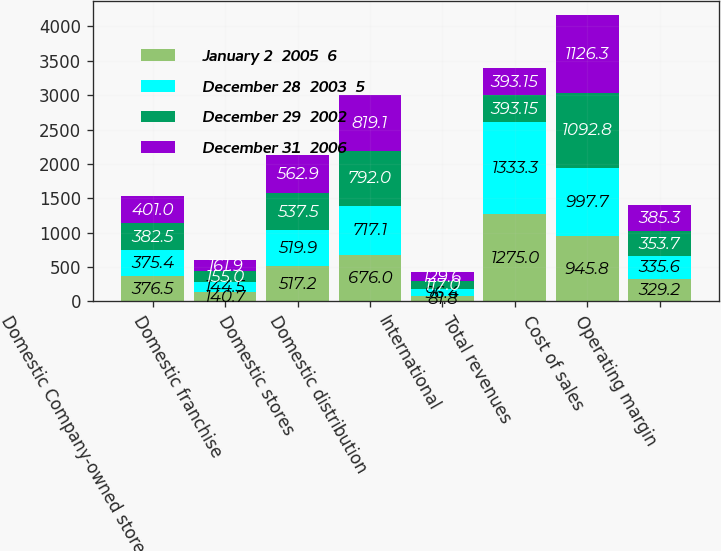Convert chart to OTSL. <chart><loc_0><loc_0><loc_500><loc_500><stacked_bar_chart><ecel><fcel>Domestic Company-owned stores<fcel>Domestic franchise<fcel>Domestic stores<fcel>Domestic distribution<fcel>International<fcel>Total revenues<fcel>Cost of sales<fcel>Operating margin<nl><fcel>January 2  2005  6<fcel>376.5<fcel>140.7<fcel>517.2<fcel>676<fcel>81.8<fcel>1275<fcel>945.8<fcel>329.2<nl><fcel>December 28  2003  5<fcel>375.4<fcel>144.5<fcel>519.9<fcel>717.1<fcel>96.4<fcel>1333.3<fcel>997.7<fcel>335.6<nl><fcel>December 29  2002<fcel>382.5<fcel>155<fcel>537.5<fcel>792<fcel>117<fcel>393.15<fcel>1092.8<fcel>353.7<nl><fcel>December 31  2006<fcel>401<fcel>161.9<fcel>562.9<fcel>819.1<fcel>129.6<fcel>393.15<fcel>1126.3<fcel>385.3<nl></chart> 